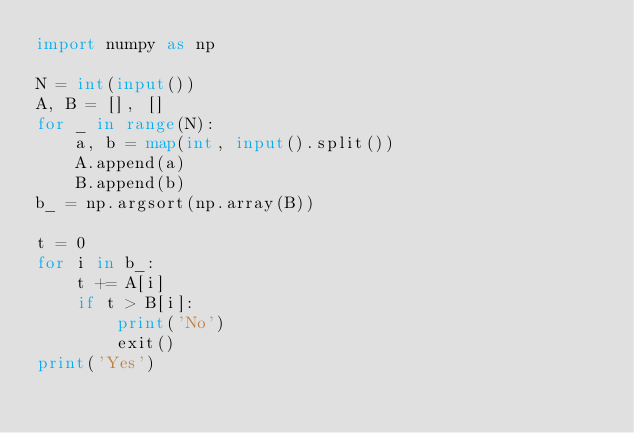<code> <loc_0><loc_0><loc_500><loc_500><_Python_>import numpy as np

N = int(input())
A, B = [], []
for _ in range(N):
    a, b = map(int, input().split())
    A.append(a)
    B.append(b)
b_ = np.argsort(np.array(B))

t = 0
for i in b_:
    t += A[i]
    if t > B[i]:
        print('No')
        exit()
print('Yes')
</code> 